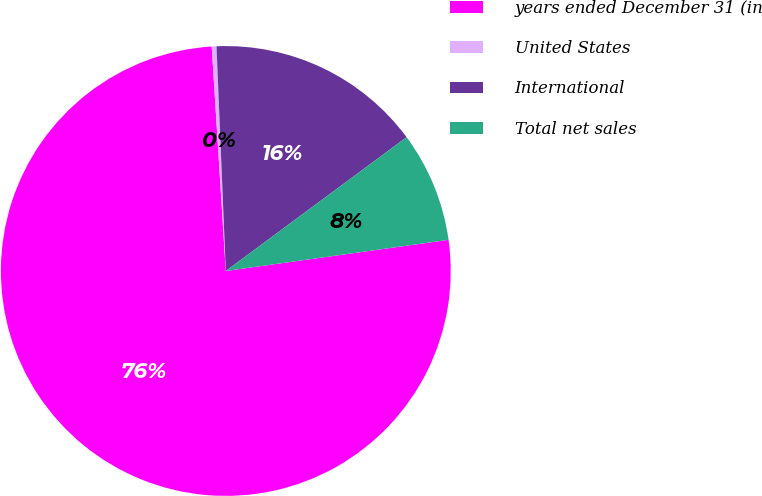Convert chart. <chart><loc_0><loc_0><loc_500><loc_500><pie_chart><fcel>years ended December 31 (in<fcel>United States<fcel>International<fcel>Total net sales<nl><fcel>76.22%<fcel>0.34%<fcel>15.52%<fcel>7.93%<nl></chart> 